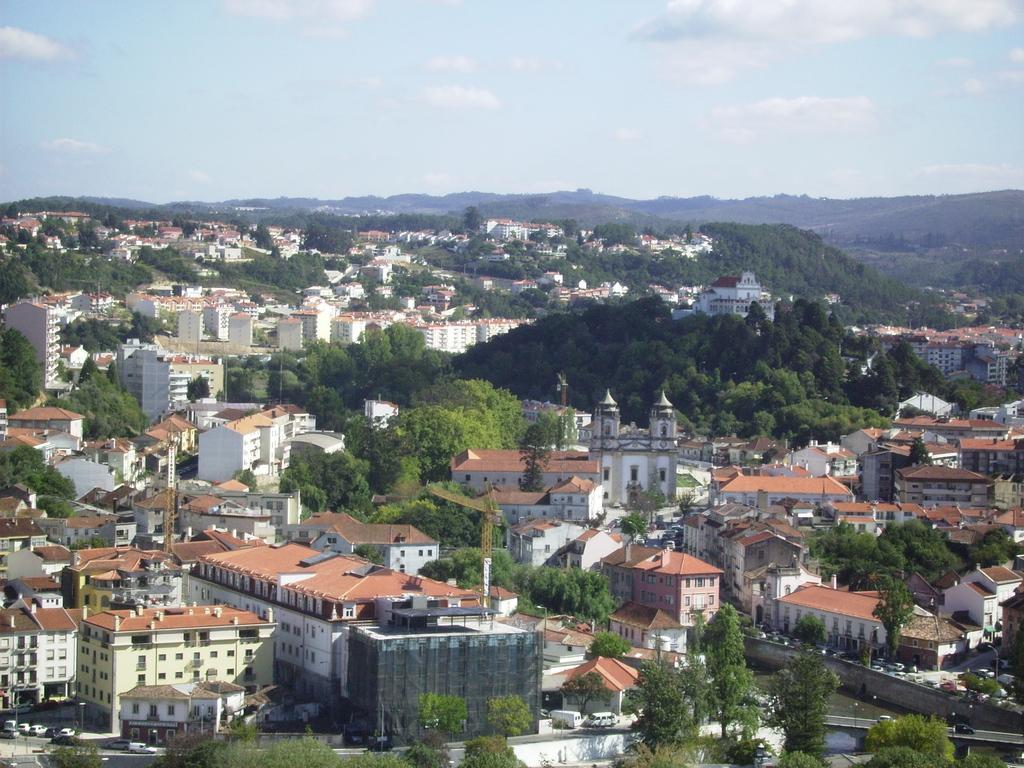Could you give a brief overview of what you see in this image? In this picture I can see buildings and trees. In the background I can see hills and the sky. 